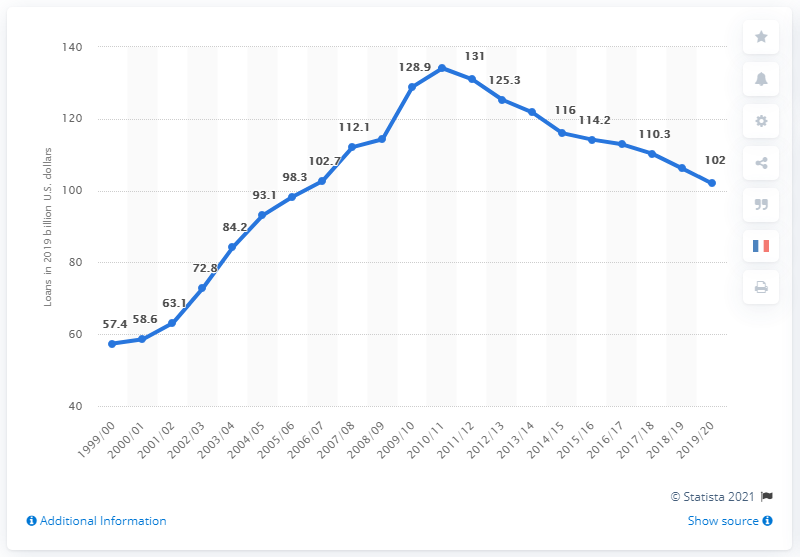Indicate a few pertinent items in this graphic. The total amount of loans offered to students in the US in the 1999/00 academic year was 57.4 billion dollars. In the academic year 2019/20, a total of 102 loans were offered to students. 